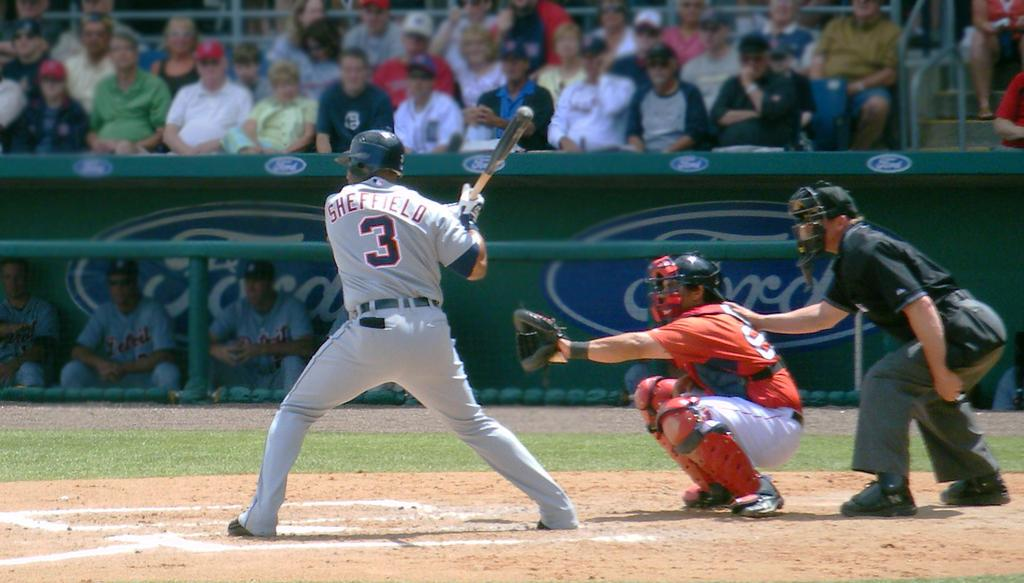<image>
Provide a brief description of the given image. a player with the number 3 on playing some baseball 